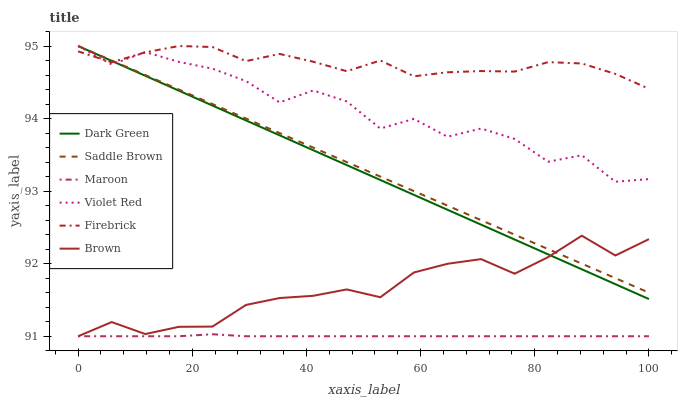Does Maroon have the minimum area under the curve?
Answer yes or no. Yes. Does Firebrick have the maximum area under the curve?
Answer yes or no. Yes. Does Violet Red have the minimum area under the curve?
Answer yes or no. No. Does Violet Red have the maximum area under the curve?
Answer yes or no. No. Is Saddle Brown the smoothest?
Answer yes or no. Yes. Is Violet Red the roughest?
Answer yes or no. Yes. Is Firebrick the smoothest?
Answer yes or no. No. Is Firebrick the roughest?
Answer yes or no. No. Does Brown have the lowest value?
Answer yes or no. Yes. Does Violet Red have the lowest value?
Answer yes or no. No. Does Dark Green have the highest value?
Answer yes or no. Yes. Does Maroon have the highest value?
Answer yes or no. No. Is Maroon less than Violet Red?
Answer yes or no. Yes. Is Firebrick greater than Maroon?
Answer yes or no. Yes. Does Maroon intersect Brown?
Answer yes or no. Yes. Is Maroon less than Brown?
Answer yes or no. No. Is Maroon greater than Brown?
Answer yes or no. No. Does Maroon intersect Violet Red?
Answer yes or no. No. 